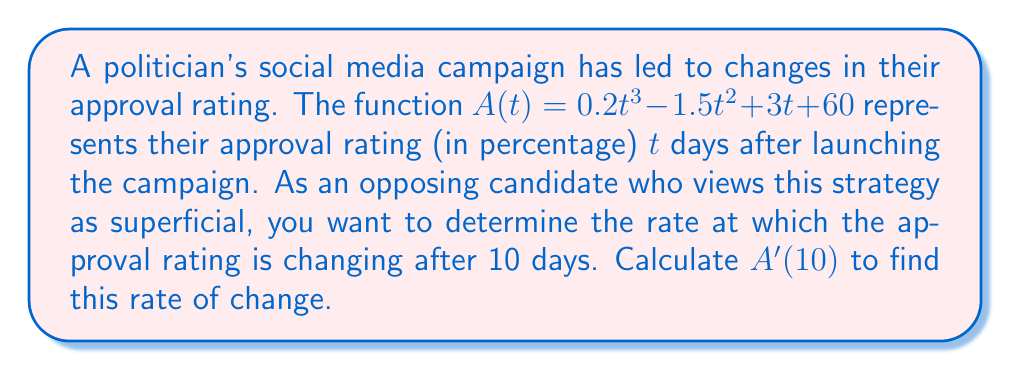Show me your answer to this math problem. To find the rate of change in the approval rating after 10 days, we need to calculate the derivative of $A(t)$ and then evaluate it at $t=10$.

1. First, let's find the derivative of $A(t)$:
   $$A(t) = 0.2t^3 - 1.5t^2 + 3t + 60$$
   $$A'(t) = 0.6t^2 - 3t + 3$$

2. Now, we need to evaluate $A'(t)$ at $t=10$:
   $$A'(10) = 0.6(10)^2 - 3(10) + 3$$
   $$= 0.6(100) - 30 + 3$$
   $$= 60 - 30 + 3$$
   $$= 33$$

The rate of change is measured in percentage points per day, as the original function $A(t)$ represents the approval rating as a percentage.
Answer: The rate of change in the politician's approval rating after 10 days is 33 percentage points per day. 